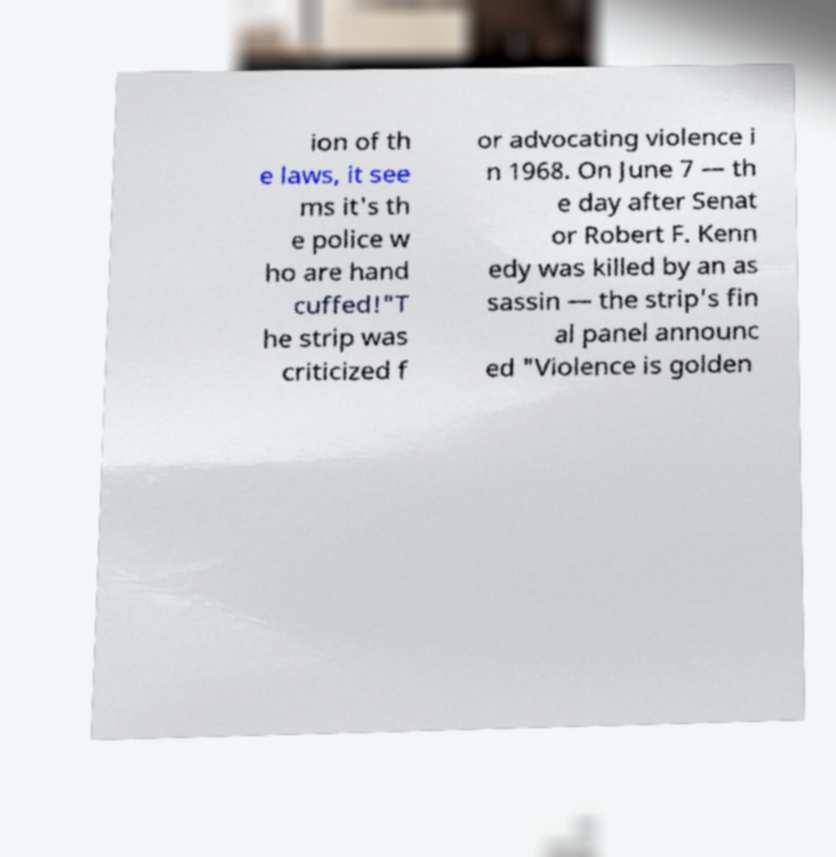Please identify and transcribe the text found in this image. ion of th e laws, it see ms it's th e police w ho are hand cuffed!"T he strip was criticized f or advocating violence i n 1968. On June 7 — th e day after Senat or Robert F. Kenn edy was killed by an as sassin — the strip's fin al panel announc ed "Violence is golden 